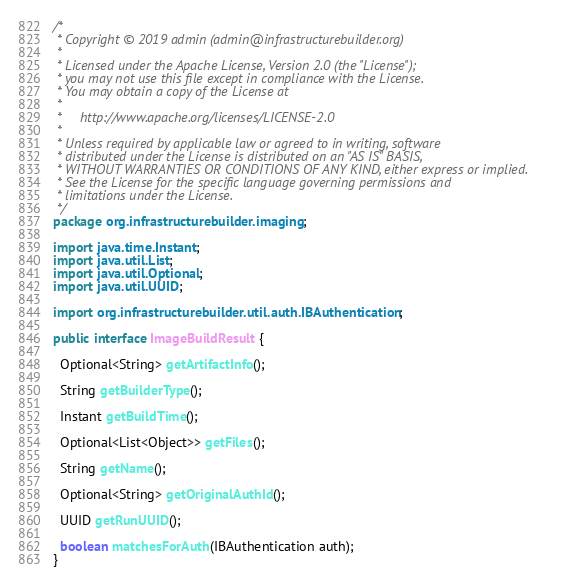Convert code to text. <code><loc_0><loc_0><loc_500><loc_500><_Java_>/*
 * Copyright © 2019 admin (admin@infrastructurebuilder.org)
 *
 * Licensed under the Apache License, Version 2.0 (the "License");
 * you may not use this file except in compliance with the License.
 * You may obtain a copy of the License at
 *
 *     http://www.apache.org/licenses/LICENSE-2.0
 *
 * Unless required by applicable law or agreed to in writing, software
 * distributed under the License is distributed on an "AS IS" BASIS,
 * WITHOUT WARRANTIES OR CONDITIONS OF ANY KIND, either express or implied.
 * See the License for the specific language governing permissions and
 * limitations under the License.
 */
package org.infrastructurebuilder.imaging;

import java.time.Instant;
import java.util.List;
import java.util.Optional;
import java.util.UUID;

import org.infrastructurebuilder.util.auth.IBAuthentication;

public interface ImageBuildResult {

  Optional<String> getArtifactInfo();

  String getBuilderType();

  Instant getBuildTime();

  Optional<List<Object>> getFiles();

  String getName();

  Optional<String> getOriginalAuthId();

  UUID getRunUUID();

  boolean matchesForAuth(IBAuthentication auth);
}
</code> 